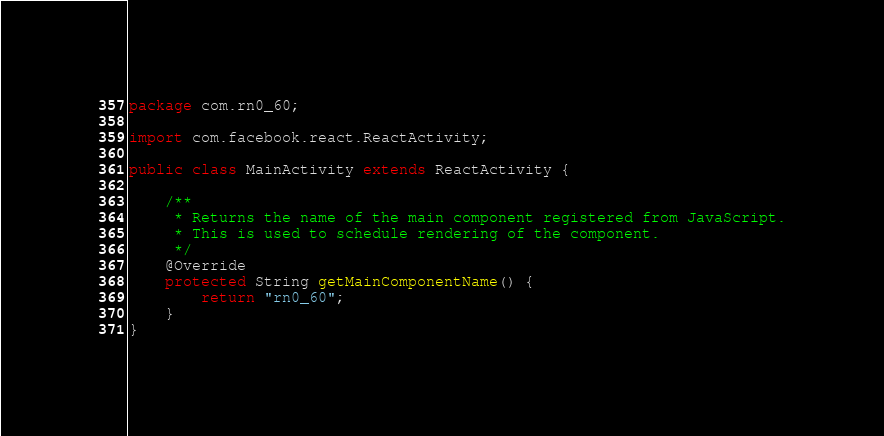<code> <loc_0><loc_0><loc_500><loc_500><_Java_>package com.rn0_60;

import com.facebook.react.ReactActivity;

public class MainActivity extends ReactActivity {

    /**
     * Returns the name of the main component registered from JavaScript.
     * This is used to schedule rendering of the component.
     */
    @Override
    protected String getMainComponentName() {
        return "rn0_60";
    }
}
</code> 